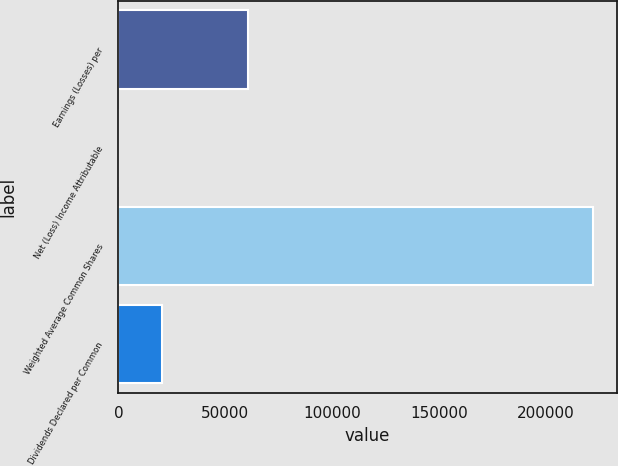<chart> <loc_0><loc_0><loc_500><loc_500><bar_chart><fcel>Earnings (Losses) per<fcel>Net (Loss) Income Attributable<fcel>Weighted Average Common Shares<fcel>Dividends Declared per Common<nl><fcel>60597.5<fcel>0.29<fcel>222190<fcel>20199.4<nl></chart> 